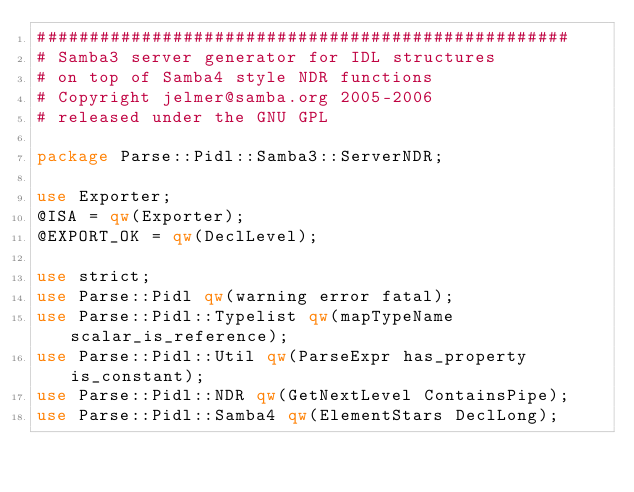<code> <loc_0><loc_0><loc_500><loc_500><_Perl_>###################################################
# Samba3 server generator for IDL structures
# on top of Samba4 style NDR functions
# Copyright jelmer@samba.org 2005-2006
# released under the GNU GPL

package Parse::Pidl::Samba3::ServerNDR;

use Exporter;
@ISA = qw(Exporter);
@EXPORT_OK = qw(DeclLevel);

use strict;
use Parse::Pidl qw(warning error fatal);
use Parse::Pidl::Typelist qw(mapTypeName scalar_is_reference);
use Parse::Pidl::Util qw(ParseExpr has_property is_constant);
use Parse::Pidl::NDR qw(GetNextLevel ContainsPipe);
use Parse::Pidl::Samba4 qw(ElementStars DeclLong);</code> 